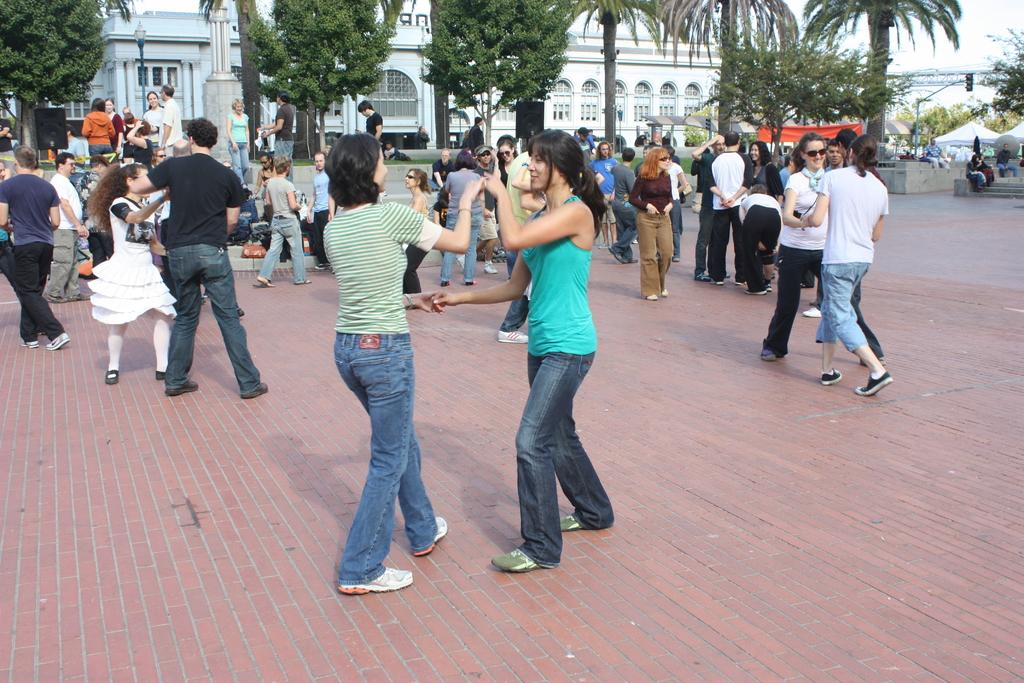What are the people in the image doing? The people in the image are dancing. What can be seen in the background of the image? There is a white color building in the background of the image. Are there any natural elements present in the image? Yes, there are trees in the image. What type of meat can be seen hanging from the trees in the image? There is no meat present in the image; it features a group of people dancing with trees and a white color building in the background. 